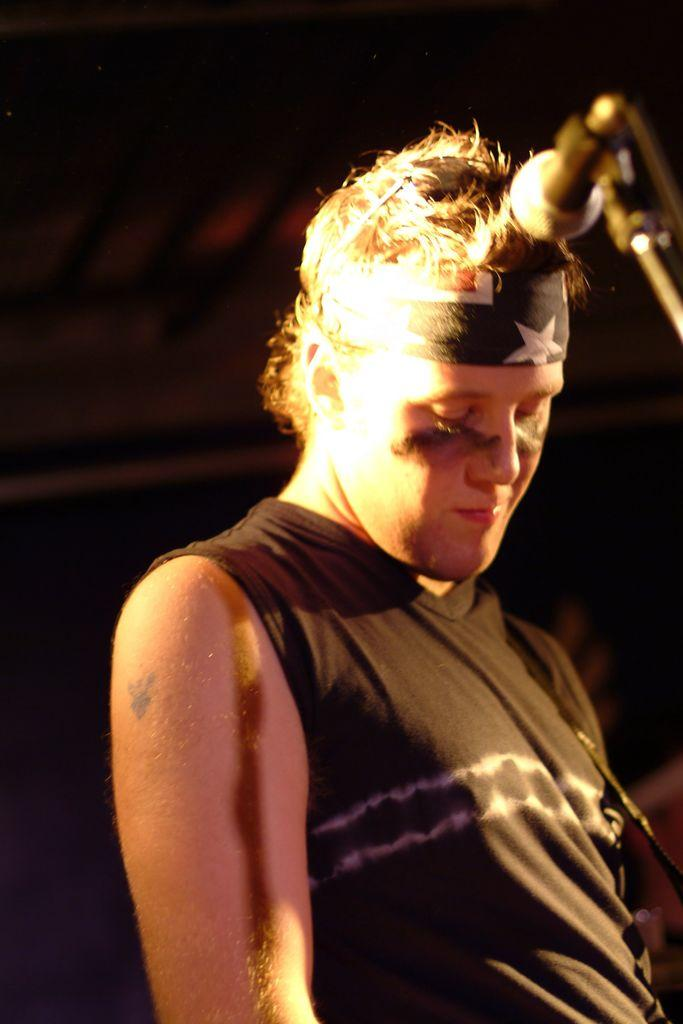Who is present in the image? There is a man in the image. What is the man wearing? The man is wearing a black color sleeveless T-shirt. Can you describe any accessories the man is wearing? The man is wearing a headband. What equipment is visible in the image? There is a mic and a mic stand in the image. What is the color of the background in the image? The background of the image is dark. Is the man playing a guitar in the image? There is no guitar present in the image. What type of destruction is happening in the background of the image? There is no destruction present in the image; the background is dark. 